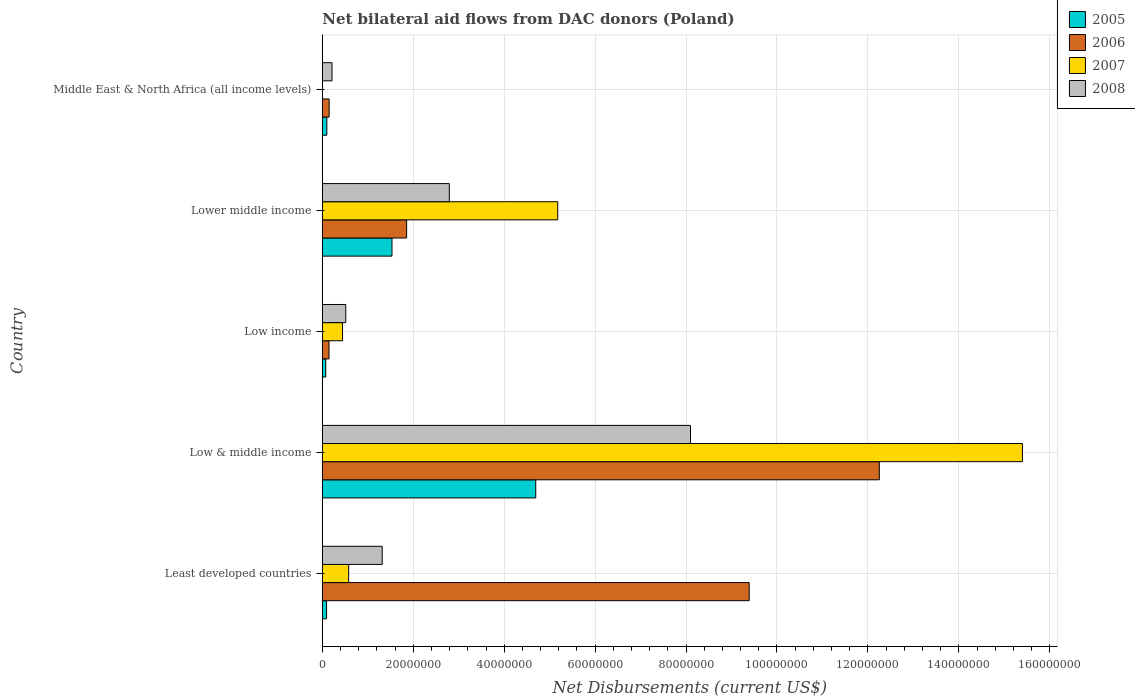Are the number of bars on each tick of the Y-axis equal?
Your answer should be very brief. No. How many bars are there on the 4th tick from the top?
Make the answer very short. 4. In how many cases, is the number of bars for a given country not equal to the number of legend labels?
Provide a succinct answer. 1. What is the net bilateral aid flows in 2007 in Low income?
Make the answer very short. 4.44e+06. Across all countries, what is the maximum net bilateral aid flows in 2006?
Your answer should be compact. 1.23e+08. What is the total net bilateral aid flows in 2008 in the graph?
Give a very brief answer. 1.29e+08. What is the difference between the net bilateral aid flows in 2007 in Low income and that in Lower middle income?
Your response must be concise. -4.73e+07. What is the difference between the net bilateral aid flows in 2006 in Least developed countries and the net bilateral aid flows in 2005 in Low & middle income?
Your answer should be very brief. 4.70e+07. What is the average net bilateral aid flows in 2006 per country?
Provide a short and direct response. 4.76e+07. What is the difference between the net bilateral aid flows in 2005 and net bilateral aid flows in 2006 in Low income?
Provide a short and direct response. -7.20e+05. In how many countries, is the net bilateral aid flows in 2006 greater than 80000000 US$?
Offer a terse response. 2. What is the ratio of the net bilateral aid flows in 2006 in Least developed countries to that in Low income?
Offer a terse response. 63.87. Is the net bilateral aid flows in 2008 in Lower middle income less than that in Middle East & North Africa (all income levels)?
Keep it short and to the point. No. What is the difference between the highest and the second highest net bilateral aid flows in 2006?
Make the answer very short. 2.86e+07. What is the difference between the highest and the lowest net bilateral aid flows in 2005?
Make the answer very short. 4.62e+07. How many countries are there in the graph?
Provide a short and direct response. 5. What is the difference between two consecutive major ticks on the X-axis?
Ensure brevity in your answer.  2.00e+07. Does the graph contain grids?
Your answer should be compact. Yes. Where does the legend appear in the graph?
Keep it short and to the point. Top right. How many legend labels are there?
Your answer should be compact. 4. How are the legend labels stacked?
Ensure brevity in your answer.  Vertical. What is the title of the graph?
Offer a very short reply. Net bilateral aid flows from DAC donors (Poland). Does "1992" appear as one of the legend labels in the graph?
Your answer should be compact. No. What is the label or title of the X-axis?
Your response must be concise. Net Disbursements (current US$). What is the label or title of the Y-axis?
Give a very brief answer. Country. What is the Net Disbursements (current US$) in 2005 in Least developed countries?
Your response must be concise. 9.30e+05. What is the Net Disbursements (current US$) of 2006 in Least developed countries?
Keep it short and to the point. 9.39e+07. What is the Net Disbursements (current US$) in 2007 in Least developed countries?
Provide a succinct answer. 5.79e+06. What is the Net Disbursements (current US$) in 2008 in Least developed countries?
Provide a succinct answer. 1.32e+07. What is the Net Disbursements (current US$) of 2005 in Low & middle income?
Your response must be concise. 4.69e+07. What is the Net Disbursements (current US$) in 2006 in Low & middle income?
Provide a short and direct response. 1.23e+08. What is the Net Disbursements (current US$) in 2007 in Low & middle income?
Your answer should be compact. 1.54e+08. What is the Net Disbursements (current US$) of 2008 in Low & middle income?
Make the answer very short. 8.10e+07. What is the Net Disbursements (current US$) in 2005 in Low income?
Give a very brief answer. 7.50e+05. What is the Net Disbursements (current US$) in 2006 in Low income?
Your response must be concise. 1.47e+06. What is the Net Disbursements (current US$) of 2007 in Low income?
Your answer should be very brief. 4.44e+06. What is the Net Disbursements (current US$) in 2008 in Low income?
Your response must be concise. 5.15e+06. What is the Net Disbursements (current US$) of 2005 in Lower middle income?
Keep it short and to the point. 1.53e+07. What is the Net Disbursements (current US$) in 2006 in Lower middle income?
Give a very brief answer. 1.85e+07. What is the Net Disbursements (current US$) in 2007 in Lower middle income?
Make the answer very short. 5.18e+07. What is the Net Disbursements (current US$) in 2008 in Lower middle income?
Offer a terse response. 2.79e+07. What is the Net Disbursements (current US$) of 2005 in Middle East & North Africa (all income levels)?
Your answer should be very brief. 9.90e+05. What is the Net Disbursements (current US$) of 2006 in Middle East & North Africa (all income levels)?
Offer a very short reply. 1.50e+06. What is the Net Disbursements (current US$) in 2008 in Middle East & North Africa (all income levels)?
Your answer should be very brief. 2.13e+06. Across all countries, what is the maximum Net Disbursements (current US$) of 2005?
Your response must be concise. 4.69e+07. Across all countries, what is the maximum Net Disbursements (current US$) of 2006?
Offer a very short reply. 1.23e+08. Across all countries, what is the maximum Net Disbursements (current US$) in 2007?
Offer a terse response. 1.54e+08. Across all countries, what is the maximum Net Disbursements (current US$) of 2008?
Offer a terse response. 8.10e+07. Across all countries, what is the minimum Net Disbursements (current US$) of 2005?
Keep it short and to the point. 7.50e+05. Across all countries, what is the minimum Net Disbursements (current US$) in 2006?
Keep it short and to the point. 1.47e+06. Across all countries, what is the minimum Net Disbursements (current US$) of 2007?
Offer a terse response. 0. Across all countries, what is the minimum Net Disbursements (current US$) of 2008?
Provide a short and direct response. 2.13e+06. What is the total Net Disbursements (current US$) of 2005 in the graph?
Keep it short and to the point. 6.49e+07. What is the total Net Disbursements (current US$) in 2006 in the graph?
Your answer should be very brief. 2.38e+08. What is the total Net Disbursements (current US$) of 2007 in the graph?
Make the answer very short. 2.16e+08. What is the total Net Disbursements (current US$) of 2008 in the graph?
Make the answer very short. 1.29e+08. What is the difference between the Net Disbursements (current US$) in 2005 in Least developed countries and that in Low & middle income?
Provide a short and direct response. -4.60e+07. What is the difference between the Net Disbursements (current US$) of 2006 in Least developed countries and that in Low & middle income?
Give a very brief answer. -2.86e+07. What is the difference between the Net Disbursements (current US$) of 2007 in Least developed countries and that in Low & middle income?
Your answer should be compact. -1.48e+08. What is the difference between the Net Disbursements (current US$) in 2008 in Least developed countries and that in Low & middle income?
Your answer should be compact. -6.78e+07. What is the difference between the Net Disbursements (current US$) in 2005 in Least developed countries and that in Low income?
Offer a very short reply. 1.80e+05. What is the difference between the Net Disbursements (current US$) of 2006 in Least developed countries and that in Low income?
Make the answer very short. 9.24e+07. What is the difference between the Net Disbursements (current US$) in 2007 in Least developed countries and that in Low income?
Offer a very short reply. 1.35e+06. What is the difference between the Net Disbursements (current US$) of 2008 in Least developed countries and that in Low income?
Provide a succinct answer. 8.02e+06. What is the difference between the Net Disbursements (current US$) in 2005 in Least developed countries and that in Lower middle income?
Offer a terse response. -1.44e+07. What is the difference between the Net Disbursements (current US$) in 2006 in Least developed countries and that in Lower middle income?
Offer a terse response. 7.54e+07. What is the difference between the Net Disbursements (current US$) in 2007 in Least developed countries and that in Lower middle income?
Provide a succinct answer. -4.60e+07. What is the difference between the Net Disbursements (current US$) of 2008 in Least developed countries and that in Lower middle income?
Your answer should be compact. -1.48e+07. What is the difference between the Net Disbursements (current US$) in 2005 in Least developed countries and that in Middle East & North Africa (all income levels)?
Your response must be concise. -6.00e+04. What is the difference between the Net Disbursements (current US$) in 2006 in Least developed countries and that in Middle East & North Africa (all income levels)?
Offer a terse response. 9.24e+07. What is the difference between the Net Disbursements (current US$) of 2008 in Least developed countries and that in Middle East & North Africa (all income levels)?
Give a very brief answer. 1.10e+07. What is the difference between the Net Disbursements (current US$) of 2005 in Low & middle income and that in Low income?
Your response must be concise. 4.62e+07. What is the difference between the Net Disbursements (current US$) of 2006 in Low & middle income and that in Low income?
Offer a terse response. 1.21e+08. What is the difference between the Net Disbursements (current US$) of 2007 in Low & middle income and that in Low income?
Give a very brief answer. 1.50e+08. What is the difference between the Net Disbursements (current US$) of 2008 in Low & middle income and that in Low income?
Offer a terse response. 7.58e+07. What is the difference between the Net Disbursements (current US$) of 2005 in Low & middle income and that in Lower middle income?
Keep it short and to the point. 3.16e+07. What is the difference between the Net Disbursements (current US$) of 2006 in Low & middle income and that in Lower middle income?
Offer a very short reply. 1.04e+08. What is the difference between the Net Disbursements (current US$) of 2007 in Low & middle income and that in Lower middle income?
Offer a terse response. 1.02e+08. What is the difference between the Net Disbursements (current US$) of 2008 in Low & middle income and that in Lower middle income?
Ensure brevity in your answer.  5.30e+07. What is the difference between the Net Disbursements (current US$) of 2005 in Low & middle income and that in Middle East & North Africa (all income levels)?
Provide a short and direct response. 4.60e+07. What is the difference between the Net Disbursements (current US$) of 2006 in Low & middle income and that in Middle East & North Africa (all income levels)?
Your answer should be compact. 1.21e+08. What is the difference between the Net Disbursements (current US$) of 2008 in Low & middle income and that in Middle East & North Africa (all income levels)?
Offer a very short reply. 7.88e+07. What is the difference between the Net Disbursements (current US$) of 2005 in Low income and that in Lower middle income?
Provide a succinct answer. -1.46e+07. What is the difference between the Net Disbursements (current US$) in 2006 in Low income and that in Lower middle income?
Your response must be concise. -1.71e+07. What is the difference between the Net Disbursements (current US$) in 2007 in Low income and that in Lower middle income?
Give a very brief answer. -4.73e+07. What is the difference between the Net Disbursements (current US$) in 2008 in Low income and that in Lower middle income?
Offer a terse response. -2.28e+07. What is the difference between the Net Disbursements (current US$) in 2008 in Low income and that in Middle East & North Africa (all income levels)?
Offer a very short reply. 3.02e+06. What is the difference between the Net Disbursements (current US$) in 2005 in Lower middle income and that in Middle East & North Africa (all income levels)?
Make the answer very short. 1.43e+07. What is the difference between the Net Disbursements (current US$) of 2006 in Lower middle income and that in Middle East & North Africa (all income levels)?
Give a very brief answer. 1.70e+07. What is the difference between the Net Disbursements (current US$) in 2008 in Lower middle income and that in Middle East & North Africa (all income levels)?
Your answer should be compact. 2.58e+07. What is the difference between the Net Disbursements (current US$) of 2005 in Least developed countries and the Net Disbursements (current US$) of 2006 in Low & middle income?
Your answer should be compact. -1.22e+08. What is the difference between the Net Disbursements (current US$) of 2005 in Least developed countries and the Net Disbursements (current US$) of 2007 in Low & middle income?
Your answer should be compact. -1.53e+08. What is the difference between the Net Disbursements (current US$) of 2005 in Least developed countries and the Net Disbursements (current US$) of 2008 in Low & middle income?
Give a very brief answer. -8.00e+07. What is the difference between the Net Disbursements (current US$) of 2006 in Least developed countries and the Net Disbursements (current US$) of 2007 in Low & middle income?
Your answer should be very brief. -6.01e+07. What is the difference between the Net Disbursements (current US$) of 2006 in Least developed countries and the Net Disbursements (current US$) of 2008 in Low & middle income?
Your answer should be compact. 1.29e+07. What is the difference between the Net Disbursements (current US$) in 2007 in Least developed countries and the Net Disbursements (current US$) in 2008 in Low & middle income?
Provide a short and direct response. -7.52e+07. What is the difference between the Net Disbursements (current US$) in 2005 in Least developed countries and the Net Disbursements (current US$) in 2006 in Low income?
Keep it short and to the point. -5.40e+05. What is the difference between the Net Disbursements (current US$) in 2005 in Least developed countries and the Net Disbursements (current US$) in 2007 in Low income?
Your response must be concise. -3.51e+06. What is the difference between the Net Disbursements (current US$) in 2005 in Least developed countries and the Net Disbursements (current US$) in 2008 in Low income?
Ensure brevity in your answer.  -4.22e+06. What is the difference between the Net Disbursements (current US$) of 2006 in Least developed countries and the Net Disbursements (current US$) of 2007 in Low income?
Make the answer very short. 8.94e+07. What is the difference between the Net Disbursements (current US$) of 2006 in Least developed countries and the Net Disbursements (current US$) of 2008 in Low income?
Make the answer very short. 8.87e+07. What is the difference between the Net Disbursements (current US$) of 2007 in Least developed countries and the Net Disbursements (current US$) of 2008 in Low income?
Your response must be concise. 6.40e+05. What is the difference between the Net Disbursements (current US$) in 2005 in Least developed countries and the Net Disbursements (current US$) in 2006 in Lower middle income?
Provide a succinct answer. -1.76e+07. What is the difference between the Net Disbursements (current US$) of 2005 in Least developed countries and the Net Disbursements (current US$) of 2007 in Lower middle income?
Offer a very short reply. -5.08e+07. What is the difference between the Net Disbursements (current US$) in 2005 in Least developed countries and the Net Disbursements (current US$) in 2008 in Lower middle income?
Keep it short and to the point. -2.70e+07. What is the difference between the Net Disbursements (current US$) in 2006 in Least developed countries and the Net Disbursements (current US$) in 2007 in Lower middle income?
Offer a terse response. 4.21e+07. What is the difference between the Net Disbursements (current US$) of 2006 in Least developed countries and the Net Disbursements (current US$) of 2008 in Lower middle income?
Your response must be concise. 6.60e+07. What is the difference between the Net Disbursements (current US$) in 2007 in Least developed countries and the Net Disbursements (current US$) in 2008 in Lower middle income?
Your answer should be compact. -2.21e+07. What is the difference between the Net Disbursements (current US$) in 2005 in Least developed countries and the Net Disbursements (current US$) in 2006 in Middle East & North Africa (all income levels)?
Your response must be concise. -5.70e+05. What is the difference between the Net Disbursements (current US$) in 2005 in Least developed countries and the Net Disbursements (current US$) in 2008 in Middle East & North Africa (all income levels)?
Offer a terse response. -1.20e+06. What is the difference between the Net Disbursements (current US$) of 2006 in Least developed countries and the Net Disbursements (current US$) of 2008 in Middle East & North Africa (all income levels)?
Keep it short and to the point. 9.18e+07. What is the difference between the Net Disbursements (current US$) of 2007 in Least developed countries and the Net Disbursements (current US$) of 2008 in Middle East & North Africa (all income levels)?
Provide a succinct answer. 3.66e+06. What is the difference between the Net Disbursements (current US$) of 2005 in Low & middle income and the Net Disbursements (current US$) of 2006 in Low income?
Provide a short and direct response. 4.55e+07. What is the difference between the Net Disbursements (current US$) in 2005 in Low & middle income and the Net Disbursements (current US$) in 2007 in Low income?
Your answer should be very brief. 4.25e+07. What is the difference between the Net Disbursements (current US$) in 2005 in Low & middle income and the Net Disbursements (current US$) in 2008 in Low income?
Your answer should be very brief. 4.18e+07. What is the difference between the Net Disbursements (current US$) of 2006 in Low & middle income and the Net Disbursements (current US$) of 2007 in Low income?
Provide a short and direct response. 1.18e+08. What is the difference between the Net Disbursements (current US$) of 2006 in Low & middle income and the Net Disbursements (current US$) of 2008 in Low income?
Your answer should be compact. 1.17e+08. What is the difference between the Net Disbursements (current US$) in 2007 in Low & middle income and the Net Disbursements (current US$) in 2008 in Low income?
Your answer should be compact. 1.49e+08. What is the difference between the Net Disbursements (current US$) of 2005 in Low & middle income and the Net Disbursements (current US$) of 2006 in Lower middle income?
Your response must be concise. 2.84e+07. What is the difference between the Net Disbursements (current US$) of 2005 in Low & middle income and the Net Disbursements (current US$) of 2007 in Lower middle income?
Provide a short and direct response. -4.84e+06. What is the difference between the Net Disbursements (current US$) in 2005 in Low & middle income and the Net Disbursements (current US$) in 2008 in Lower middle income?
Keep it short and to the point. 1.90e+07. What is the difference between the Net Disbursements (current US$) of 2006 in Low & middle income and the Net Disbursements (current US$) of 2007 in Lower middle income?
Your answer should be very brief. 7.07e+07. What is the difference between the Net Disbursements (current US$) of 2006 in Low & middle income and the Net Disbursements (current US$) of 2008 in Lower middle income?
Your answer should be compact. 9.46e+07. What is the difference between the Net Disbursements (current US$) in 2007 in Low & middle income and the Net Disbursements (current US$) in 2008 in Lower middle income?
Ensure brevity in your answer.  1.26e+08. What is the difference between the Net Disbursements (current US$) of 2005 in Low & middle income and the Net Disbursements (current US$) of 2006 in Middle East & North Africa (all income levels)?
Your response must be concise. 4.54e+07. What is the difference between the Net Disbursements (current US$) in 2005 in Low & middle income and the Net Disbursements (current US$) in 2008 in Middle East & North Africa (all income levels)?
Make the answer very short. 4.48e+07. What is the difference between the Net Disbursements (current US$) in 2006 in Low & middle income and the Net Disbursements (current US$) in 2008 in Middle East & North Africa (all income levels)?
Make the answer very short. 1.20e+08. What is the difference between the Net Disbursements (current US$) in 2007 in Low & middle income and the Net Disbursements (current US$) in 2008 in Middle East & North Africa (all income levels)?
Provide a succinct answer. 1.52e+08. What is the difference between the Net Disbursements (current US$) in 2005 in Low income and the Net Disbursements (current US$) in 2006 in Lower middle income?
Offer a terse response. -1.78e+07. What is the difference between the Net Disbursements (current US$) of 2005 in Low income and the Net Disbursements (current US$) of 2007 in Lower middle income?
Offer a terse response. -5.10e+07. What is the difference between the Net Disbursements (current US$) in 2005 in Low income and the Net Disbursements (current US$) in 2008 in Lower middle income?
Make the answer very short. -2.72e+07. What is the difference between the Net Disbursements (current US$) of 2006 in Low income and the Net Disbursements (current US$) of 2007 in Lower middle income?
Your answer should be compact. -5.03e+07. What is the difference between the Net Disbursements (current US$) of 2006 in Low income and the Net Disbursements (current US$) of 2008 in Lower middle income?
Make the answer very short. -2.65e+07. What is the difference between the Net Disbursements (current US$) of 2007 in Low income and the Net Disbursements (current US$) of 2008 in Lower middle income?
Give a very brief answer. -2.35e+07. What is the difference between the Net Disbursements (current US$) in 2005 in Low income and the Net Disbursements (current US$) in 2006 in Middle East & North Africa (all income levels)?
Your answer should be compact. -7.50e+05. What is the difference between the Net Disbursements (current US$) in 2005 in Low income and the Net Disbursements (current US$) in 2008 in Middle East & North Africa (all income levels)?
Give a very brief answer. -1.38e+06. What is the difference between the Net Disbursements (current US$) in 2006 in Low income and the Net Disbursements (current US$) in 2008 in Middle East & North Africa (all income levels)?
Your response must be concise. -6.60e+05. What is the difference between the Net Disbursements (current US$) in 2007 in Low income and the Net Disbursements (current US$) in 2008 in Middle East & North Africa (all income levels)?
Keep it short and to the point. 2.31e+06. What is the difference between the Net Disbursements (current US$) in 2005 in Lower middle income and the Net Disbursements (current US$) in 2006 in Middle East & North Africa (all income levels)?
Make the answer very short. 1.38e+07. What is the difference between the Net Disbursements (current US$) in 2005 in Lower middle income and the Net Disbursements (current US$) in 2008 in Middle East & North Africa (all income levels)?
Provide a succinct answer. 1.32e+07. What is the difference between the Net Disbursements (current US$) of 2006 in Lower middle income and the Net Disbursements (current US$) of 2008 in Middle East & North Africa (all income levels)?
Offer a very short reply. 1.64e+07. What is the difference between the Net Disbursements (current US$) of 2007 in Lower middle income and the Net Disbursements (current US$) of 2008 in Middle East & North Africa (all income levels)?
Offer a very short reply. 4.96e+07. What is the average Net Disbursements (current US$) of 2005 per country?
Your response must be concise. 1.30e+07. What is the average Net Disbursements (current US$) in 2006 per country?
Your answer should be very brief. 4.76e+07. What is the average Net Disbursements (current US$) in 2007 per country?
Offer a terse response. 4.32e+07. What is the average Net Disbursements (current US$) of 2008 per country?
Keep it short and to the point. 2.59e+07. What is the difference between the Net Disbursements (current US$) of 2005 and Net Disbursements (current US$) of 2006 in Least developed countries?
Your response must be concise. -9.30e+07. What is the difference between the Net Disbursements (current US$) in 2005 and Net Disbursements (current US$) in 2007 in Least developed countries?
Offer a very short reply. -4.86e+06. What is the difference between the Net Disbursements (current US$) of 2005 and Net Disbursements (current US$) of 2008 in Least developed countries?
Give a very brief answer. -1.22e+07. What is the difference between the Net Disbursements (current US$) in 2006 and Net Disbursements (current US$) in 2007 in Least developed countries?
Provide a short and direct response. 8.81e+07. What is the difference between the Net Disbursements (current US$) in 2006 and Net Disbursements (current US$) in 2008 in Least developed countries?
Your answer should be very brief. 8.07e+07. What is the difference between the Net Disbursements (current US$) in 2007 and Net Disbursements (current US$) in 2008 in Least developed countries?
Ensure brevity in your answer.  -7.38e+06. What is the difference between the Net Disbursements (current US$) in 2005 and Net Disbursements (current US$) in 2006 in Low & middle income?
Give a very brief answer. -7.56e+07. What is the difference between the Net Disbursements (current US$) in 2005 and Net Disbursements (current US$) in 2007 in Low & middle income?
Provide a succinct answer. -1.07e+08. What is the difference between the Net Disbursements (current US$) in 2005 and Net Disbursements (current US$) in 2008 in Low & middle income?
Your answer should be very brief. -3.40e+07. What is the difference between the Net Disbursements (current US$) of 2006 and Net Disbursements (current US$) of 2007 in Low & middle income?
Your answer should be very brief. -3.15e+07. What is the difference between the Net Disbursements (current US$) of 2006 and Net Disbursements (current US$) of 2008 in Low & middle income?
Provide a short and direct response. 4.15e+07. What is the difference between the Net Disbursements (current US$) of 2007 and Net Disbursements (current US$) of 2008 in Low & middle income?
Make the answer very short. 7.30e+07. What is the difference between the Net Disbursements (current US$) of 2005 and Net Disbursements (current US$) of 2006 in Low income?
Keep it short and to the point. -7.20e+05. What is the difference between the Net Disbursements (current US$) of 2005 and Net Disbursements (current US$) of 2007 in Low income?
Give a very brief answer. -3.69e+06. What is the difference between the Net Disbursements (current US$) in 2005 and Net Disbursements (current US$) in 2008 in Low income?
Offer a terse response. -4.40e+06. What is the difference between the Net Disbursements (current US$) in 2006 and Net Disbursements (current US$) in 2007 in Low income?
Provide a short and direct response. -2.97e+06. What is the difference between the Net Disbursements (current US$) of 2006 and Net Disbursements (current US$) of 2008 in Low income?
Your answer should be compact. -3.68e+06. What is the difference between the Net Disbursements (current US$) in 2007 and Net Disbursements (current US$) in 2008 in Low income?
Your answer should be very brief. -7.10e+05. What is the difference between the Net Disbursements (current US$) in 2005 and Net Disbursements (current US$) in 2006 in Lower middle income?
Provide a short and direct response. -3.22e+06. What is the difference between the Net Disbursements (current US$) of 2005 and Net Disbursements (current US$) of 2007 in Lower middle income?
Offer a terse response. -3.65e+07. What is the difference between the Net Disbursements (current US$) in 2005 and Net Disbursements (current US$) in 2008 in Lower middle income?
Ensure brevity in your answer.  -1.26e+07. What is the difference between the Net Disbursements (current US$) of 2006 and Net Disbursements (current US$) of 2007 in Lower middle income?
Provide a succinct answer. -3.32e+07. What is the difference between the Net Disbursements (current US$) of 2006 and Net Disbursements (current US$) of 2008 in Lower middle income?
Make the answer very short. -9.39e+06. What is the difference between the Net Disbursements (current US$) of 2007 and Net Disbursements (current US$) of 2008 in Lower middle income?
Provide a short and direct response. 2.38e+07. What is the difference between the Net Disbursements (current US$) of 2005 and Net Disbursements (current US$) of 2006 in Middle East & North Africa (all income levels)?
Your answer should be compact. -5.10e+05. What is the difference between the Net Disbursements (current US$) of 2005 and Net Disbursements (current US$) of 2008 in Middle East & North Africa (all income levels)?
Ensure brevity in your answer.  -1.14e+06. What is the difference between the Net Disbursements (current US$) in 2006 and Net Disbursements (current US$) in 2008 in Middle East & North Africa (all income levels)?
Keep it short and to the point. -6.30e+05. What is the ratio of the Net Disbursements (current US$) of 2005 in Least developed countries to that in Low & middle income?
Offer a very short reply. 0.02. What is the ratio of the Net Disbursements (current US$) of 2006 in Least developed countries to that in Low & middle income?
Ensure brevity in your answer.  0.77. What is the ratio of the Net Disbursements (current US$) of 2007 in Least developed countries to that in Low & middle income?
Provide a succinct answer. 0.04. What is the ratio of the Net Disbursements (current US$) in 2008 in Least developed countries to that in Low & middle income?
Make the answer very short. 0.16. What is the ratio of the Net Disbursements (current US$) of 2005 in Least developed countries to that in Low income?
Keep it short and to the point. 1.24. What is the ratio of the Net Disbursements (current US$) in 2006 in Least developed countries to that in Low income?
Ensure brevity in your answer.  63.87. What is the ratio of the Net Disbursements (current US$) of 2007 in Least developed countries to that in Low income?
Offer a very short reply. 1.3. What is the ratio of the Net Disbursements (current US$) of 2008 in Least developed countries to that in Low income?
Your answer should be compact. 2.56. What is the ratio of the Net Disbursements (current US$) of 2005 in Least developed countries to that in Lower middle income?
Your response must be concise. 0.06. What is the ratio of the Net Disbursements (current US$) in 2006 in Least developed countries to that in Lower middle income?
Offer a terse response. 5.06. What is the ratio of the Net Disbursements (current US$) in 2007 in Least developed countries to that in Lower middle income?
Give a very brief answer. 0.11. What is the ratio of the Net Disbursements (current US$) of 2008 in Least developed countries to that in Lower middle income?
Your answer should be compact. 0.47. What is the ratio of the Net Disbursements (current US$) in 2005 in Least developed countries to that in Middle East & North Africa (all income levels)?
Offer a terse response. 0.94. What is the ratio of the Net Disbursements (current US$) in 2006 in Least developed countries to that in Middle East & North Africa (all income levels)?
Provide a succinct answer. 62.59. What is the ratio of the Net Disbursements (current US$) of 2008 in Least developed countries to that in Middle East & North Africa (all income levels)?
Give a very brief answer. 6.18. What is the ratio of the Net Disbursements (current US$) in 2005 in Low & middle income to that in Low income?
Give a very brief answer. 62.59. What is the ratio of the Net Disbursements (current US$) in 2006 in Low & middle income to that in Low income?
Your answer should be very brief. 83.34. What is the ratio of the Net Disbursements (current US$) in 2007 in Low & middle income to that in Low income?
Offer a very short reply. 34.68. What is the ratio of the Net Disbursements (current US$) of 2008 in Low & middle income to that in Low income?
Give a very brief answer. 15.72. What is the ratio of the Net Disbursements (current US$) of 2005 in Low & middle income to that in Lower middle income?
Your answer should be compact. 3.06. What is the ratio of the Net Disbursements (current US$) of 2006 in Low & middle income to that in Lower middle income?
Offer a terse response. 6.61. What is the ratio of the Net Disbursements (current US$) of 2007 in Low & middle income to that in Lower middle income?
Your answer should be very brief. 2.97. What is the ratio of the Net Disbursements (current US$) of 2008 in Low & middle income to that in Lower middle income?
Offer a terse response. 2.9. What is the ratio of the Net Disbursements (current US$) of 2005 in Low & middle income to that in Middle East & North Africa (all income levels)?
Provide a succinct answer. 47.41. What is the ratio of the Net Disbursements (current US$) in 2006 in Low & middle income to that in Middle East & North Africa (all income levels)?
Give a very brief answer. 81.67. What is the ratio of the Net Disbursements (current US$) in 2008 in Low & middle income to that in Middle East & North Africa (all income levels)?
Keep it short and to the point. 38.02. What is the ratio of the Net Disbursements (current US$) of 2005 in Low income to that in Lower middle income?
Offer a very short reply. 0.05. What is the ratio of the Net Disbursements (current US$) in 2006 in Low income to that in Lower middle income?
Your response must be concise. 0.08. What is the ratio of the Net Disbursements (current US$) of 2007 in Low income to that in Lower middle income?
Your answer should be compact. 0.09. What is the ratio of the Net Disbursements (current US$) in 2008 in Low income to that in Lower middle income?
Make the answer very short. 0.18. What is the ratio of the Net Disbursements (current US$) of 2005 in Low income to that in Middle East & North Africa (all income levels)?
Offer a terse response. 0.76. What is the ratio of the Net Disbursements (current US$) in 2008 in Low income to that in Middle East & North Africa (all income levels)?
Your answer should be compact. 2.42. What is the ratio of the Net Disbursements (current US$) of 2005 in Lower middle income to that in Middle East & North Africa (all income levels)?
Offer a terse response. 15.47. What is the ratio of the Net Disbursements (current US$) in 2006 in Lower middle income to that in Middle East & North Africa (all income levels)?
Your answer should be compact. 12.36. What is the ratio of the Net Disbursements (current US$) of 2008 in Lower middle income to that in Middle East & North Africa (all income levels)?
Make the answer very short. 13.11. What is the difference between the highest and the second highest Net Disbursements (current US$) of 2005?
Keep it short and to the point. 3.16e+07. What is the difference between the highest and the second highest Net Disbursements (current US$) of 2006?
Offer a very short reply. 2.86e+07. What is the difference between the highest and the second highest Net Disbursements (current US$) of 2007?
Keep it short and to the point. 1.02e+08. What is the difference between the highest and the second highest Net Disbursements (current US$) of 2008?
Provide a short and direct response. 5.30e+07. What is the difference between the highest and the lowest Net Disbursements (current US$) in 2005?
Your answer should be compact. 4.62e+07. What is the difference between the highest and the lowest Net Disbursements (current US$) of 2006?
Offer a terse response. 1.21e+08. What is the difference between the highest and the lowest Net Disbursements (current US$) of 2007?
Make the answer very short. 1.54e+08. What is the difference between the highest and the lowest Net Disbursements (current US$) of 2008?
Your answer should be compact. 7.88e+07. 